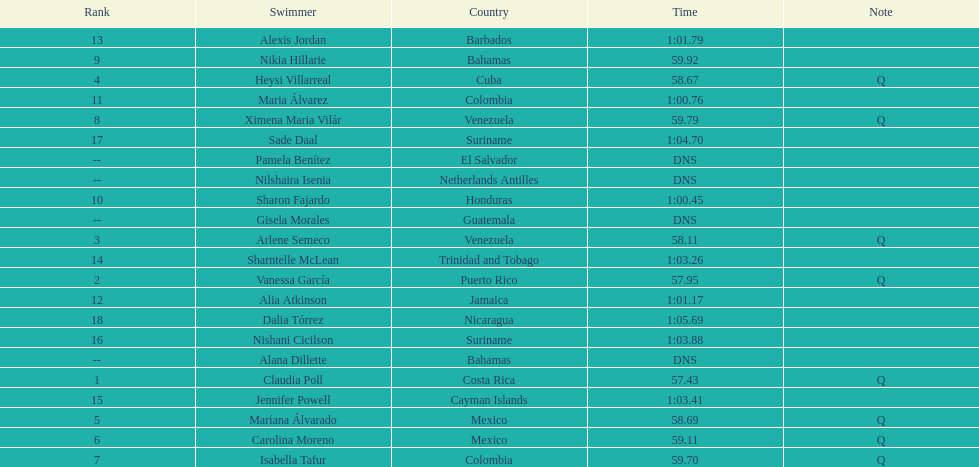What swimmer had the top or first rank? Claudia Poll. 